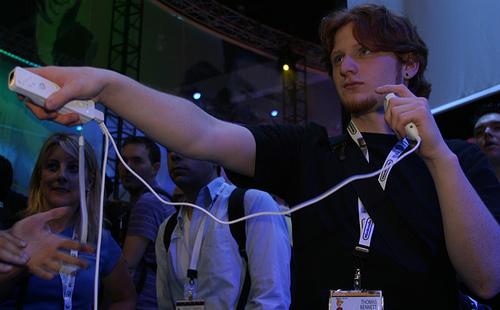Is he going to sing into the wiimote?
Concise answer only. No. Does this man have facial hair?
Keep it brief. Yes. What is in the man's ear?
Write a very short answer. Earring. 